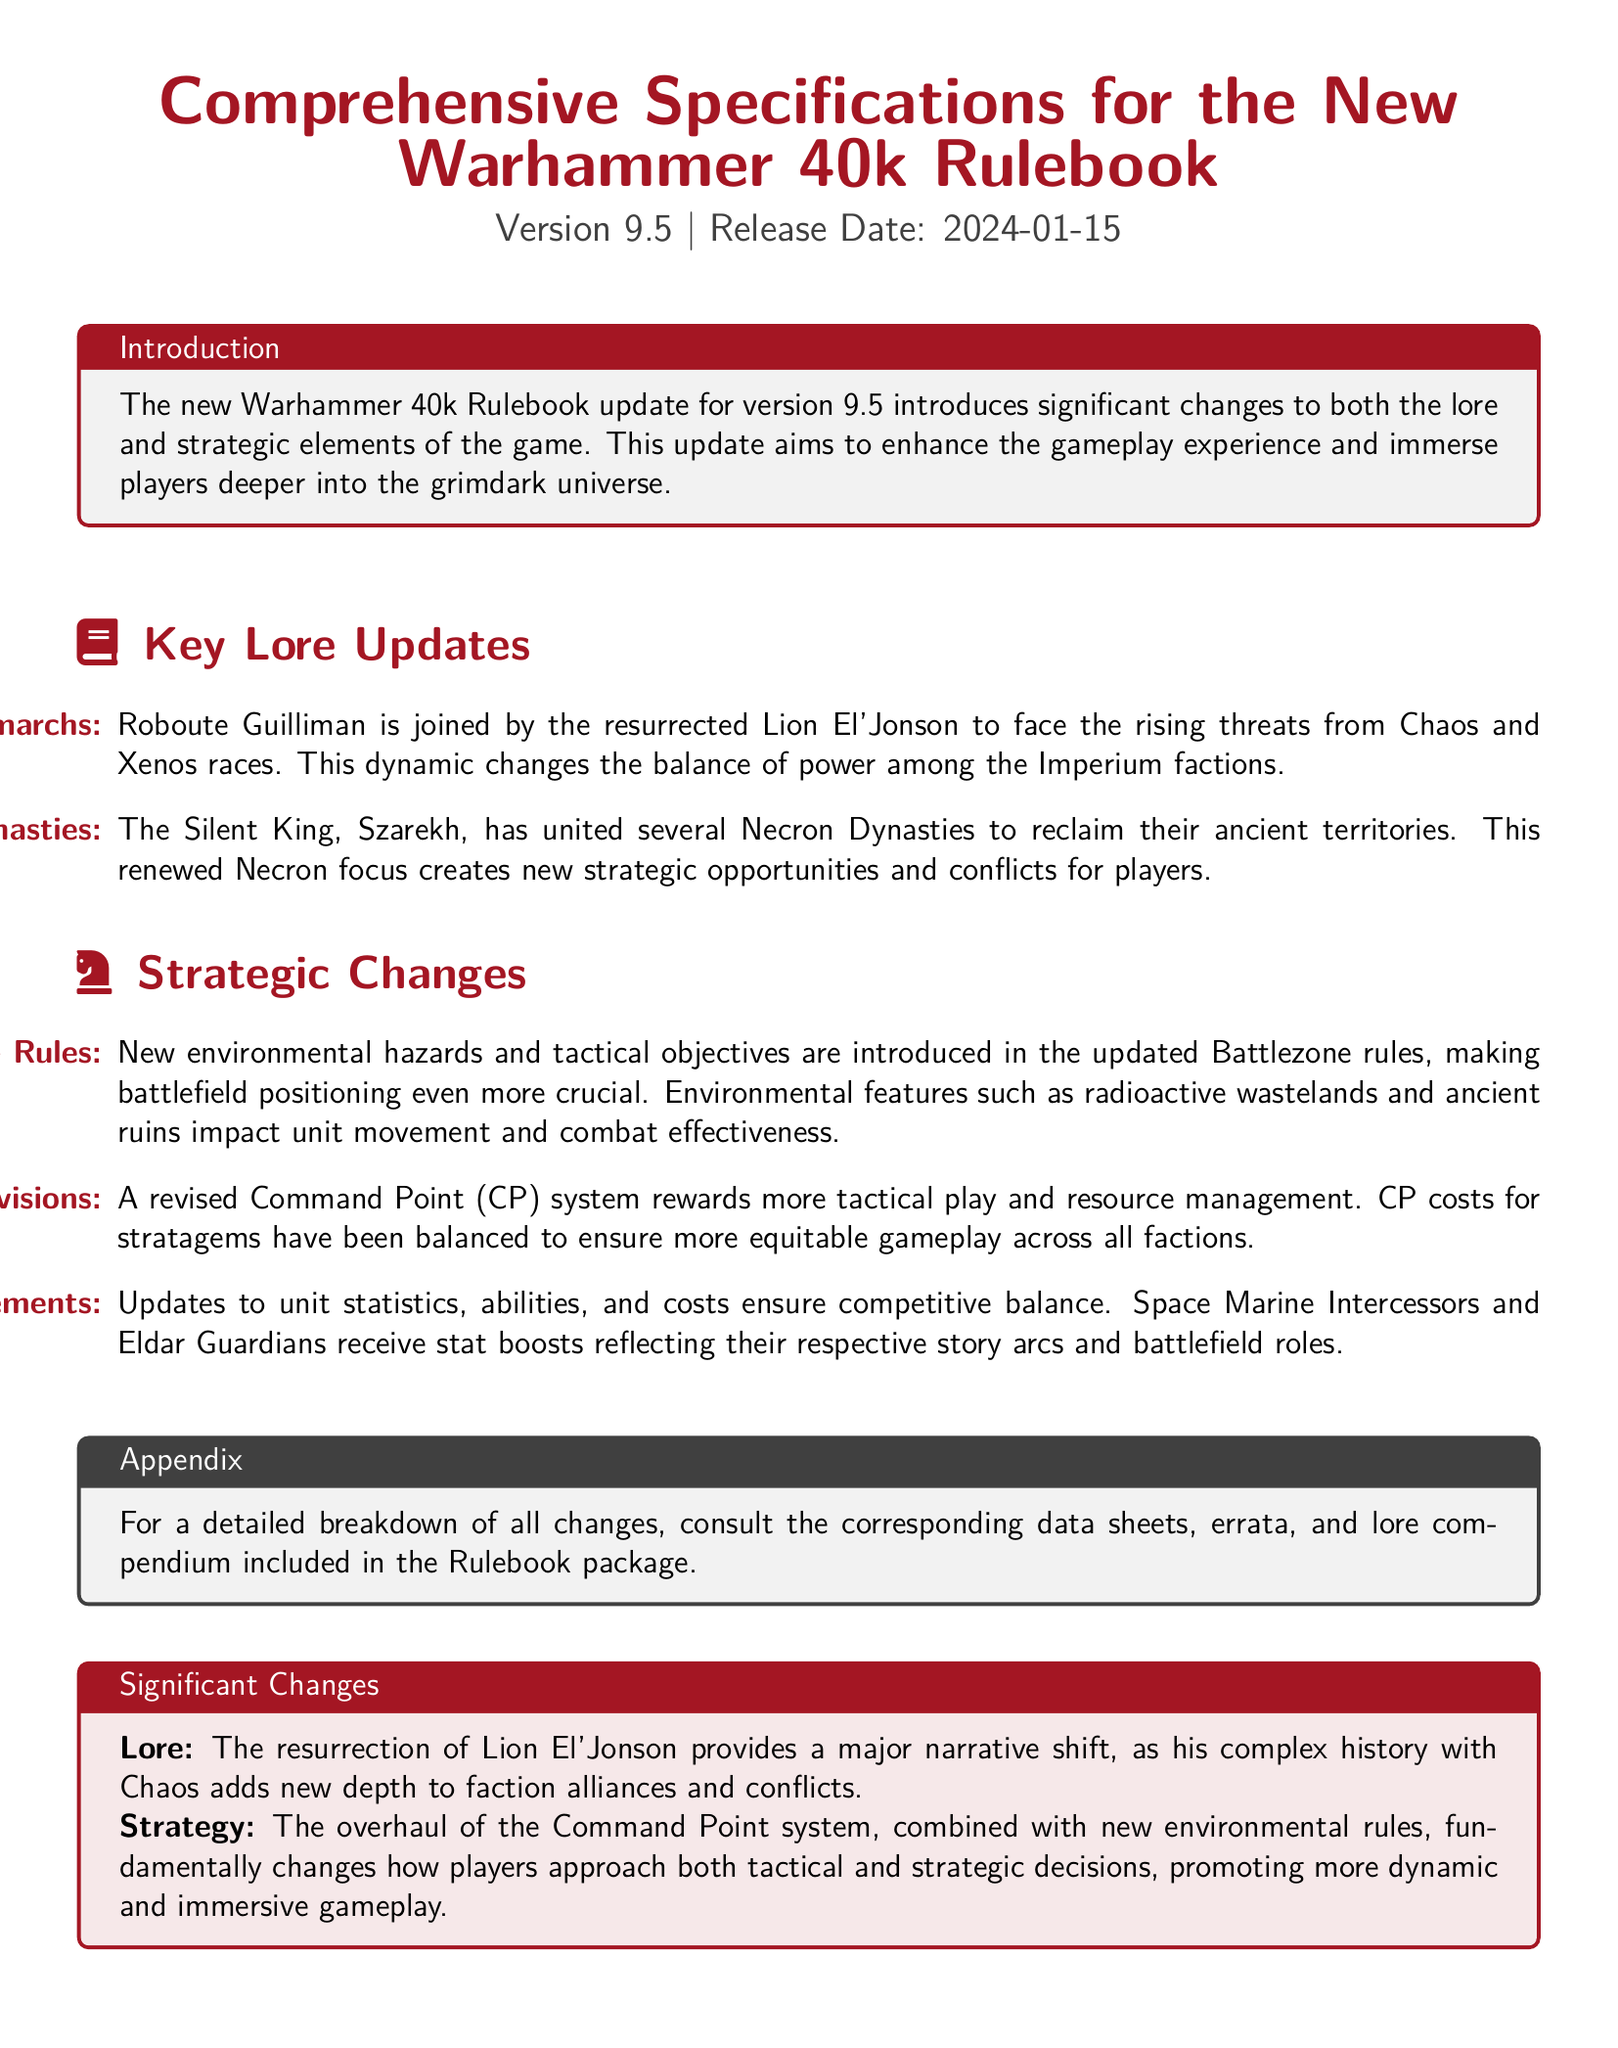What is the version of the new rulebook? The version of the new rulebook is stated as Version 9.5.
Answer: Version 9.5 What is the release date of the new Warhammer 40k rulebook? The document specifies the release date as 2024-01-15.
Answer: 2024-01-15 Who is the resurrected Primarch mentioned in the lore updates? The lore includes the return of Roboute Guilliman and Lion El'Jonson.
Answer: Lion El'Jonson What notable structure affects unit effectiveness in the new Battlezone rules? The new rules introduce environmental features that impact unit movement and combat effectiveness.
Answer: Environmental features How does the Command Point system change in the new rulebook? The document mentions a revised Command Point system that rewards more tactical play and resource management.
Answer: Revised Command Point system Which factions' units receive stat boosts in the updates? The updates mention stat boosts for Space Marine Intercessors and Eldar Guardians.
Answer: Space Marine Intercessors and Eldar Guardians What significant lore change involves the Necrons? The news states that the Silent King, Szarekh, has united several Necron Dynasties.
Answer: United several Necron Dynasties What type of updates does the appendix mention are included in the rulebook package? The appendix states that there are data sheets, errata, and lore compendium included.
Answer: Data sheets, errata, and lore compendium What is the color used for section titles in the document? The section titles are formatted using the color imperial red.
Answer: Imperial red 